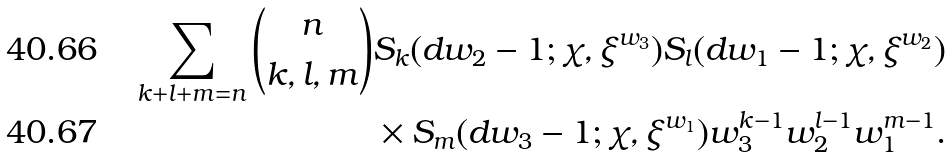<formula> <loc_0><loc_0><loc_500><loc_500>\sum _ { k + l + m = n } \binom { n } { k , l , m } & S _ { k } ( d w _ { 2 } - 1 ; \chi , \xi ^ { w _ { 3 } } ) S _ { l } ( d w _ { 1 } - 1 ; \chi , \xi ^ { w _ { 2 } } ) \\ & \times S _ { m } ( d w _ { 3 } - 1 ; \chi , \xi ^ { w _ { 1 } } ) w _ { 3 } ^ { k - 1 } w _ { 2 } ^ { l - 1 } w _ { 1 } ^ { m - 1 } .</formula> 